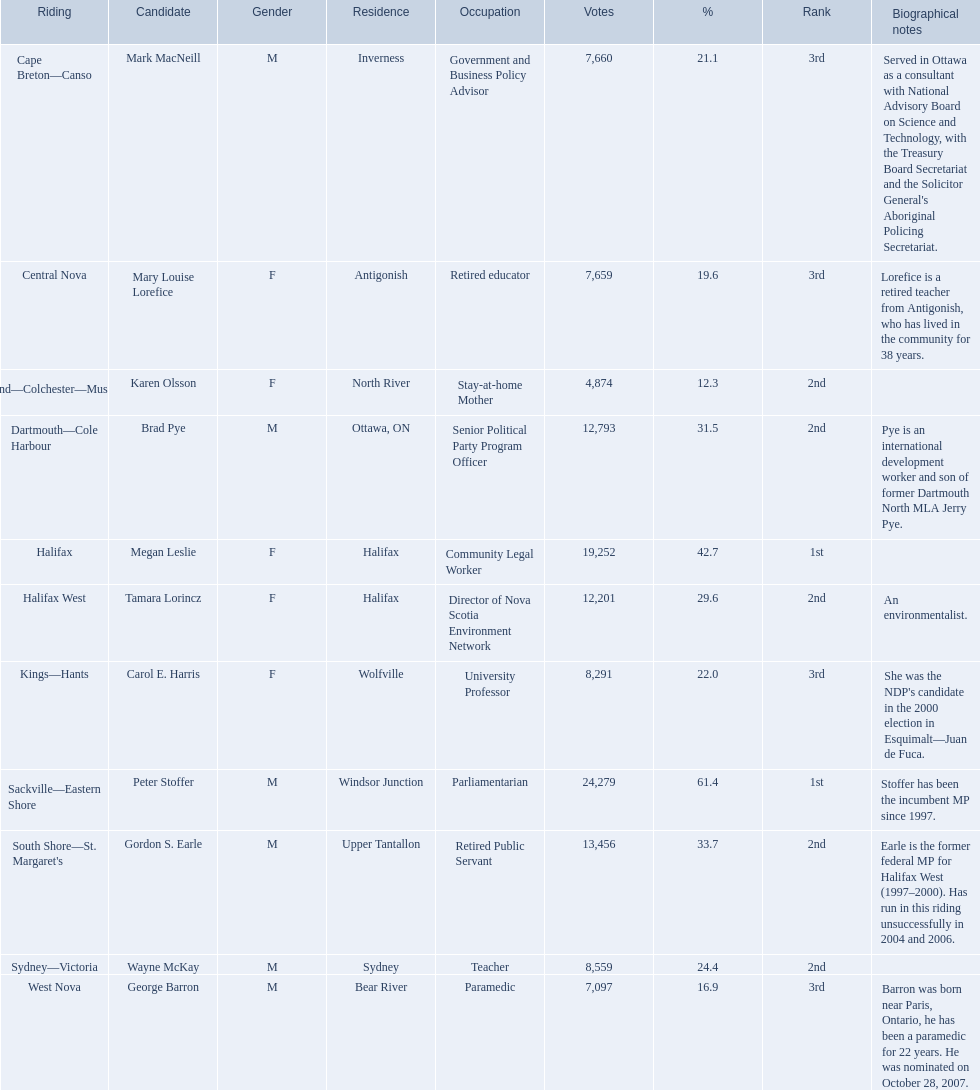What was the number of votes macneill obtained? 7,660. What was the number of votes olsson obtained? 4,874. Who had a higher vote count between macneil and olsson? Mark MacNeill. 